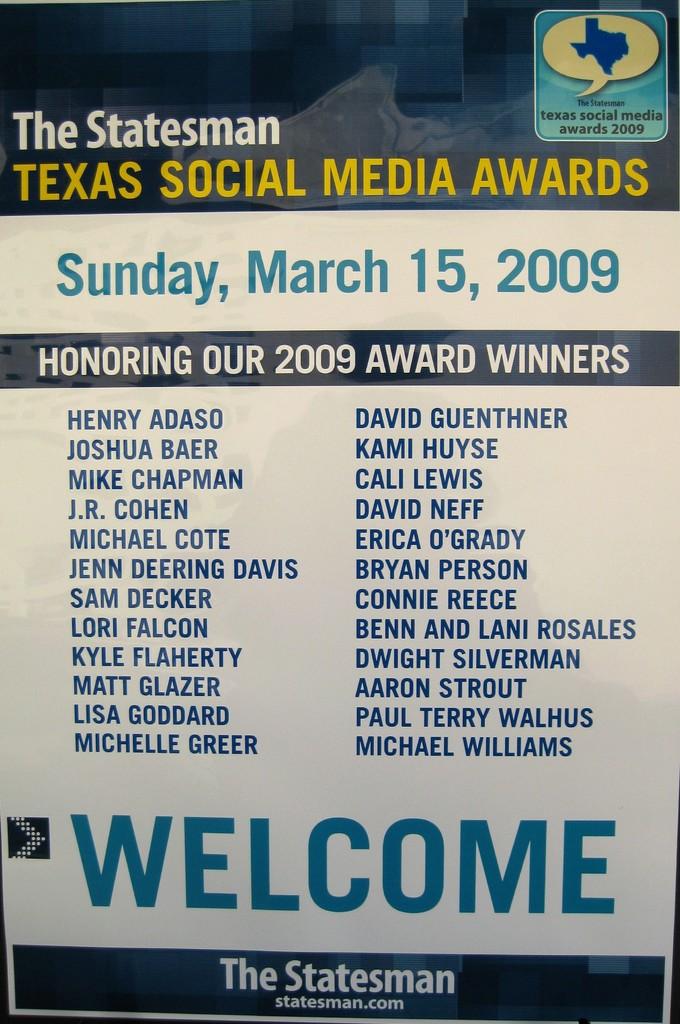Who are the winners?
Offer a terse response. Henry adaso. What time does the award ceremony start?
Provide a short and direct response. Unanswerable. 